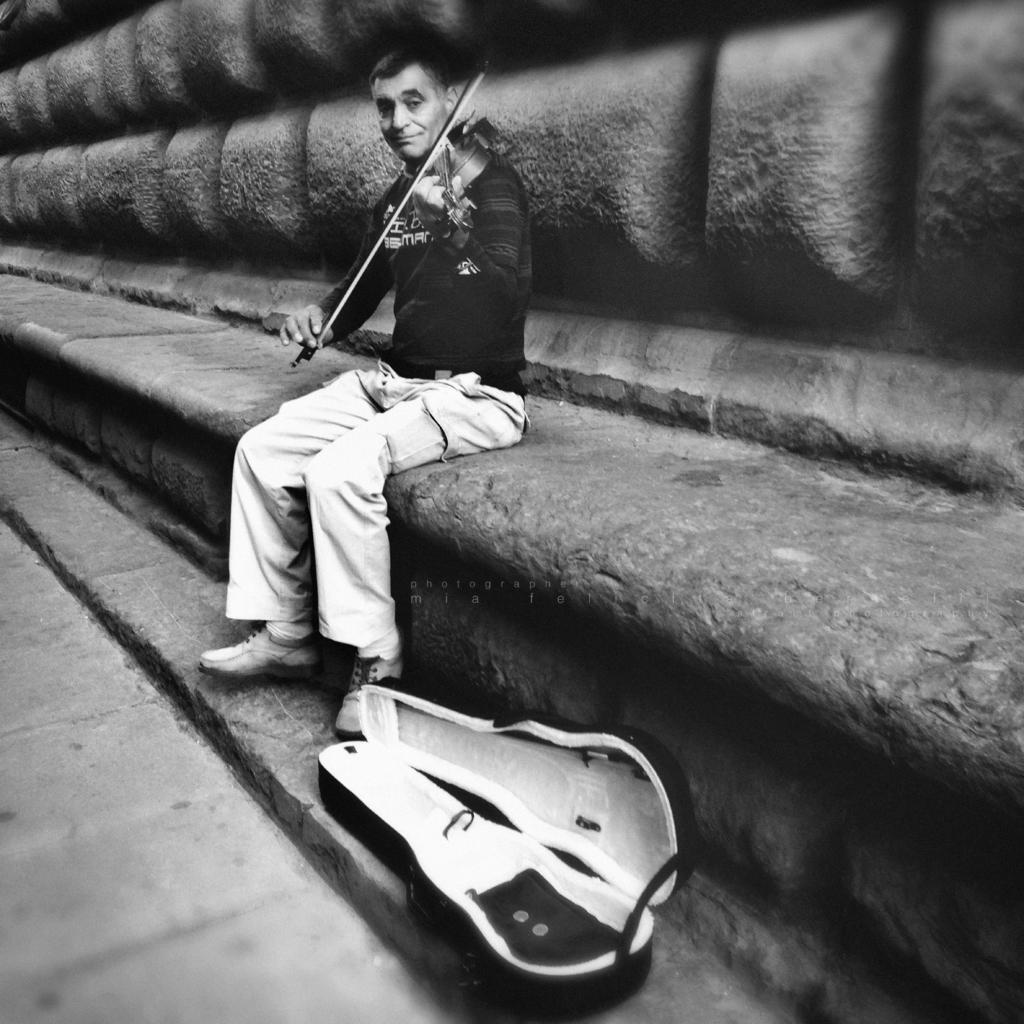Could you give a brief overview of what you see in this image? In the picture we can see a stone bench path and a wall and on it we can see a person sitting on it and playing a violin, holding it by hand and near to him on the floor we can see a violin cover box. 